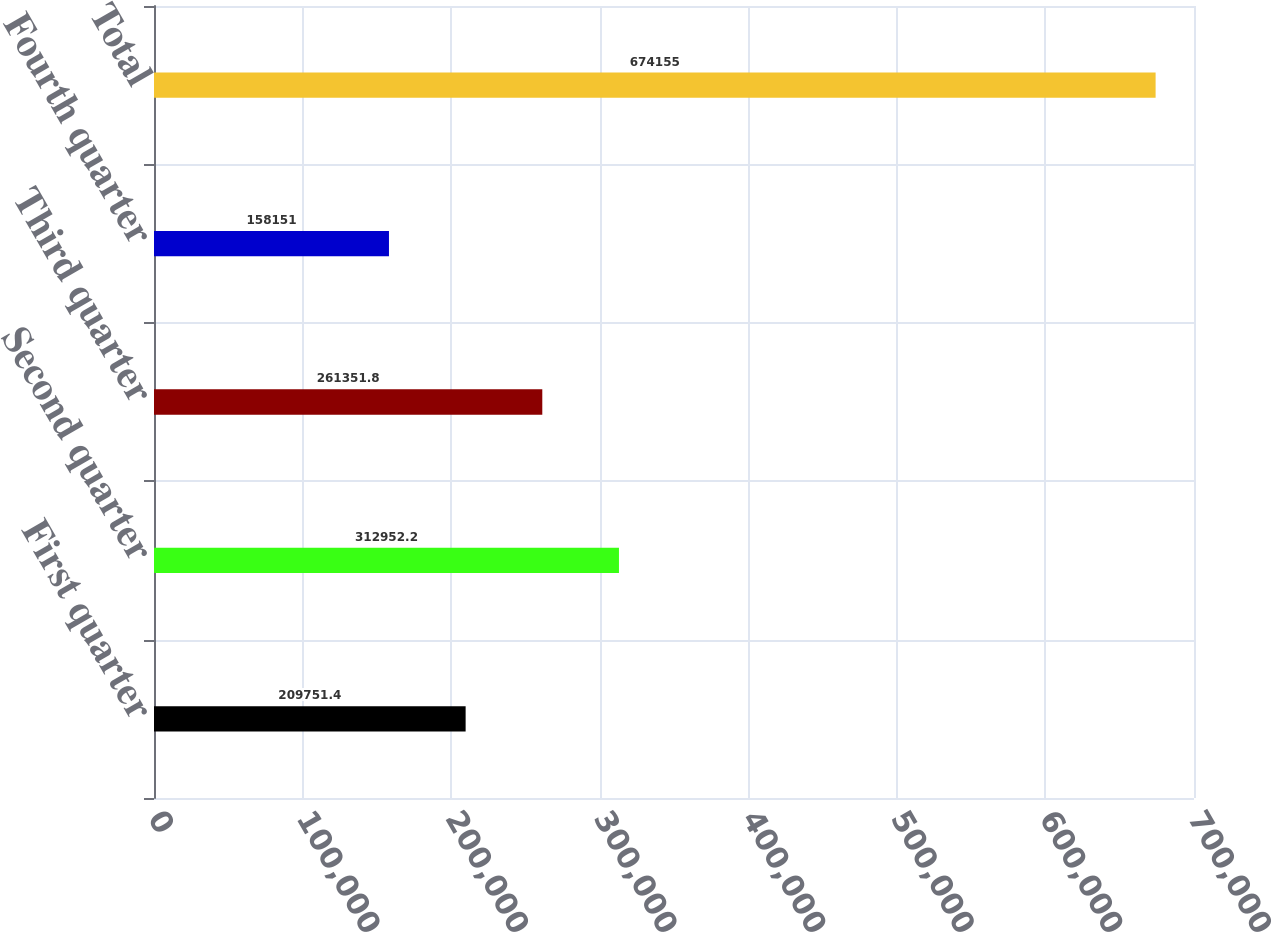Convert chart. <chart><loc_0><loc_0><loc_500><loc_500><bar_chart><fcel>First quarter<fcel>Second quarter<fcel>Third quarter<fcel>Fourth quarter<fcel>Total<nl><fcel>209751<fcel>312952<fcel>261352<fcel>158151<fcel>674155<nl></chart> 